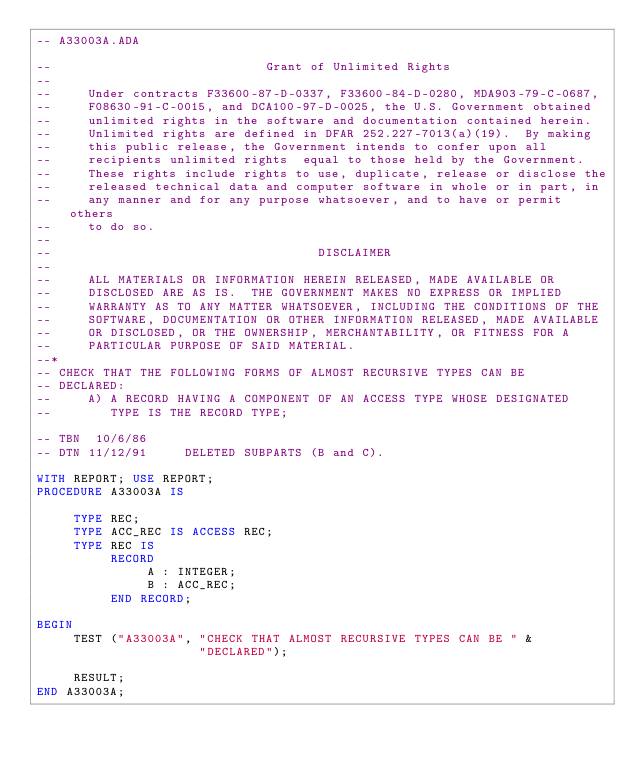<code> <loc_0><loc_0><loc_500><loc_500><_Ada_>-- A33003A.ADA

--                             Grant of Unlimited Rights
--
--     Under contracts F33600-87-D-0337, F33600-84-D-0280, MDA903-79-C-0687,
--     F08630-91-C-0015, and DCA100-97-D-0025, the U.S. Government obtained 
--     unlimited rights in the software and documentation contained herein.
--     Unlimited rights are defined in DFAR 252.227-7013(a)(19).  By making 
--     this public release, the Government intends to confer upon all 
--     recipients unlimited rights  equal to those held by the Government.  
--     These rights include rights to use, duplicate, release or disclose the 
--     released technical data and computer software in whole or in part, in 
--     any manner and for any purpose whatsoever, and to have or permit others 
--     to do so.
--
--                                    DISCLAIMER
--
--     ALL MATERIALS OR INFORMATION HEREIN RELEASED, MADE AVAILABLE OR
--     DISCLOSED ARE AS IS.  THE GOVERNMENT MAKES NO EXPRESS OR IMPLIED 
--     WARRANTY AS TO ANY MATTER WHATSOEVER, INCLUDING THE CONDITIONS OF THE
--     SOFTWARE, DOCUMENTATION OR OTHER INFORMATION RELEASED, MADE AVAILABLE 
--     OR DISCLOSED, OR THE OWNERSHIP, MERCHANTABILITY, OR FITNESS FOR A
--     PARTICULAR PURPOSE OF SAID MATERIAL.
--*
-- CHECK THAT THE FOLLOWING FORMS OF ALMOST RECURSIVE TYPES CAN BE
-- DECLARED:
--     A) A RECORD HAVING A COMPONENT OF AN ACCESS TYPE WHOSE DESIGNATED
--        TYPE IS THE RECORD TYPE;

-- TBN  10/6/86
-- DTN 11/12/91     DELETED SUBPARTS (B and C).

WITH REPORT; USE REPORT;
PROCEDURE A33003A IS

     TYPE REC;
     TYPE ACC_REC IS ACCESS REC;
     TYPE REC IS
          RECORD
               A : INTEGER;
               B : ACC_REC;
          END RECORD;

BEGIN
     TEST ("A33003A", "CHECK THAT ALMOST RECURSIVE TYPES CAN BE " &
                      "DECLARED");

     RESULT;
END A33003A;
</code> 